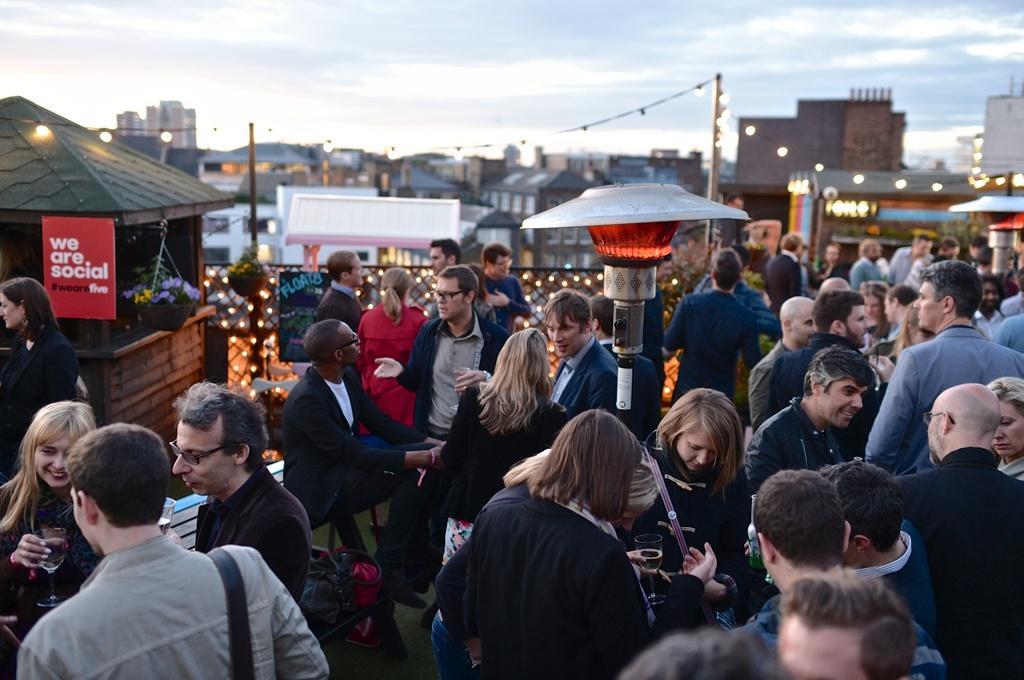How would you summarize this image in a sentence or two? This image is clicked outside. There are so many persons in the middle. There are so many stalls in the middle. There is sky at the top. There are buildings in the middle. There is sky at the top. 